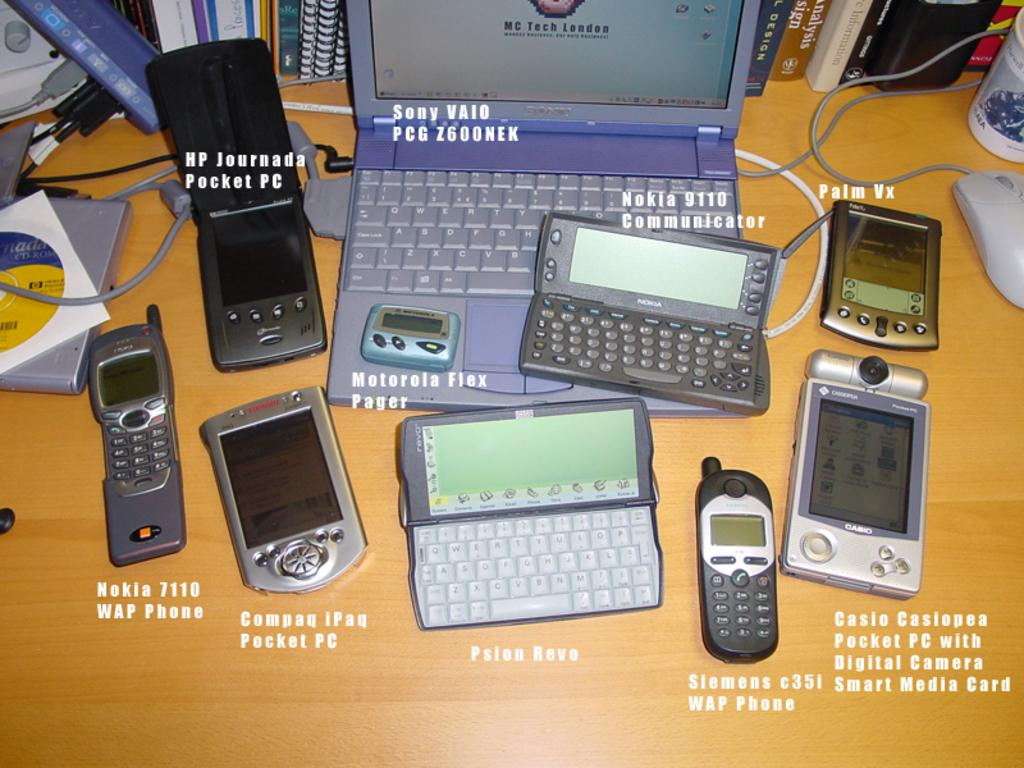<image>
Create a compact narrative representing the image presented. a laptop with the word Sony under it 